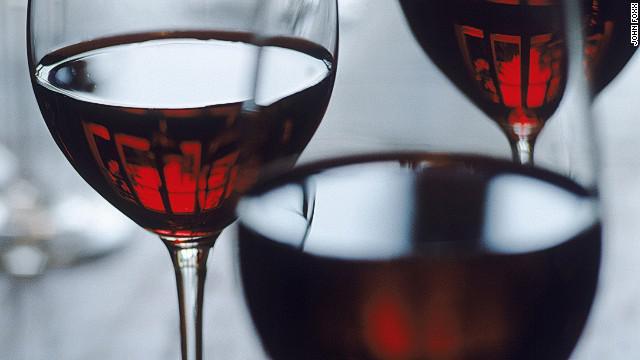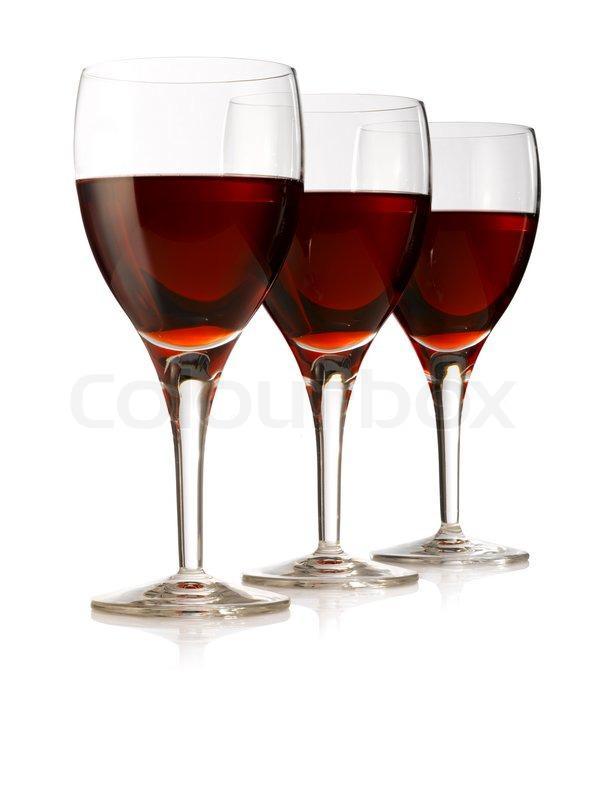The first image is the image on the left, the second image is the image on the right. Examine the images to the left and right. Is the description "At least one glass of wine is active and swirling around the wine glass." accurate? Answer yes or no. No. The first image is the image on the left, the second image is the image on the right. Examine the images to the left and right. Is the description "An image shows red wine splashing up the side of at least one stemmed glass." accurate? Answer yes or no. No. 